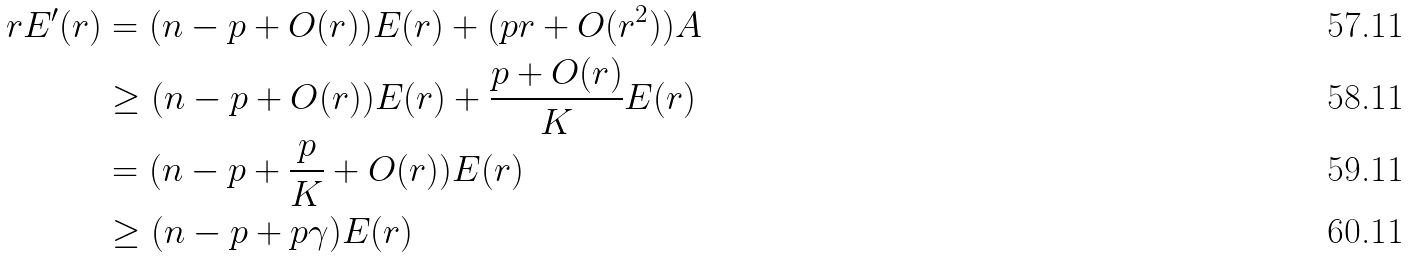<formula> <loc_0><loc_0><loc_500><loc_500>r E ^ { \prime } ( r ) & = ( n - p + O ( r ) ) E ( r ) + ( p r + O ( r ^ { 2 } ) ) A \\ & \geq ( n - p + O ( r ) ) E ( r ) + \frac { p + O ( r ) } { K } E ( r ) \\ & = ( n - p + \frac { p } { K } + O ( r ) ) E ( r ) \\ & \geq ( n - p + p \gamma ) E ( r )</formula> 